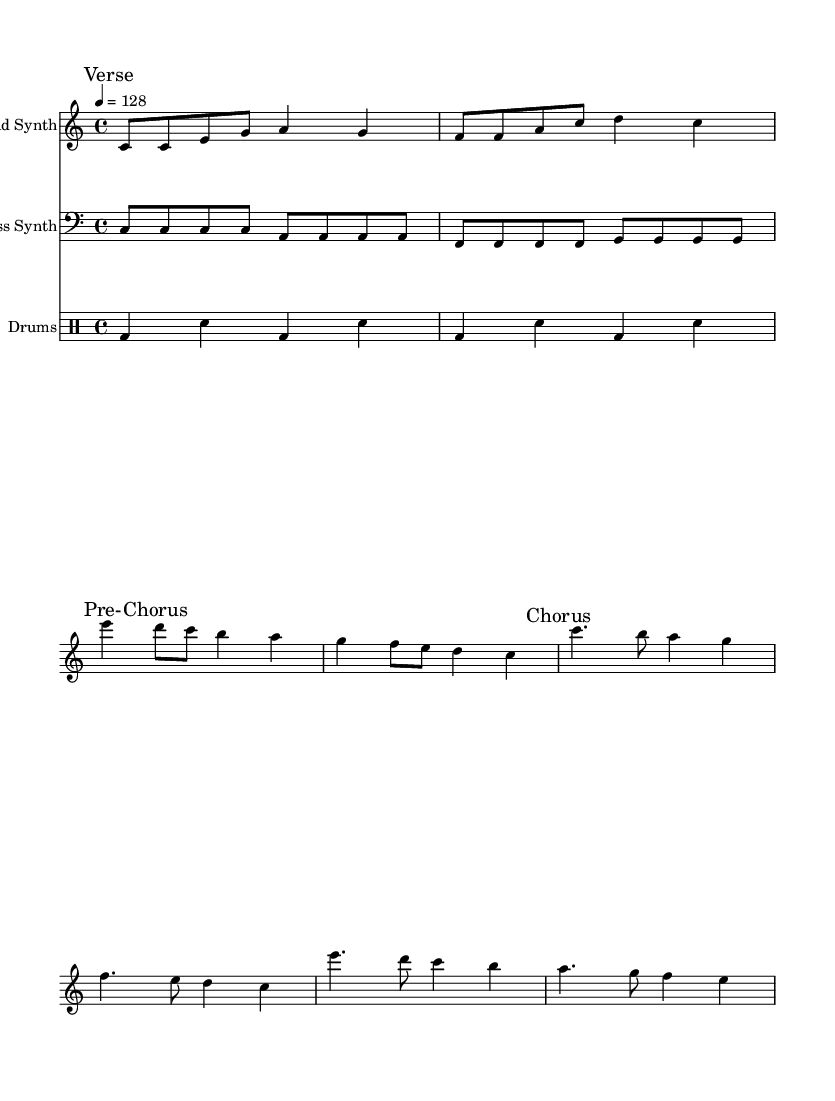What is the key signature of this music? The key signature is indicated at the beginning of the staff and shows no sharps or flats, confirming that it is C major.
Answer: C major What is the time signature of the piece? The time signature is shown at the beginning of the score and indicates four beats per measure, which is 4/4 time.
Answer: 4/4 What is the tempo marking for this piece? The tempo marking is given as "4 = 128", meaning there should be 128 beats per minute. This indicates a fast tempo typical for dance music.
Answer: 128 How many measures are there in the Lead Synth section? By counting the number of measures presented in the "Lead Synth" part, we see that there are eight measures total.
Answer: 8 What is the main theme of the lyrics? The lyrics focus on the struggle of balancing work and personal life, referencing the pressures of work and the need for healthy choices amid convenience.
Answer: Balancing work and personal life Which section of the song has a faster pace: Verse or Chorus? The tempo remains consistent throughout all sections since they are all set to the same BPM; however, the Chorus often contains more driving rhythms that can feel faster in execution.
Answer: Chorus What forms the accompaniment in the music? The accompaniment is provided by the Bass Synth and Drums, which support the Lead Synth melody while maintaining a dance vibe.
Answer: Bass Synth and Drums 